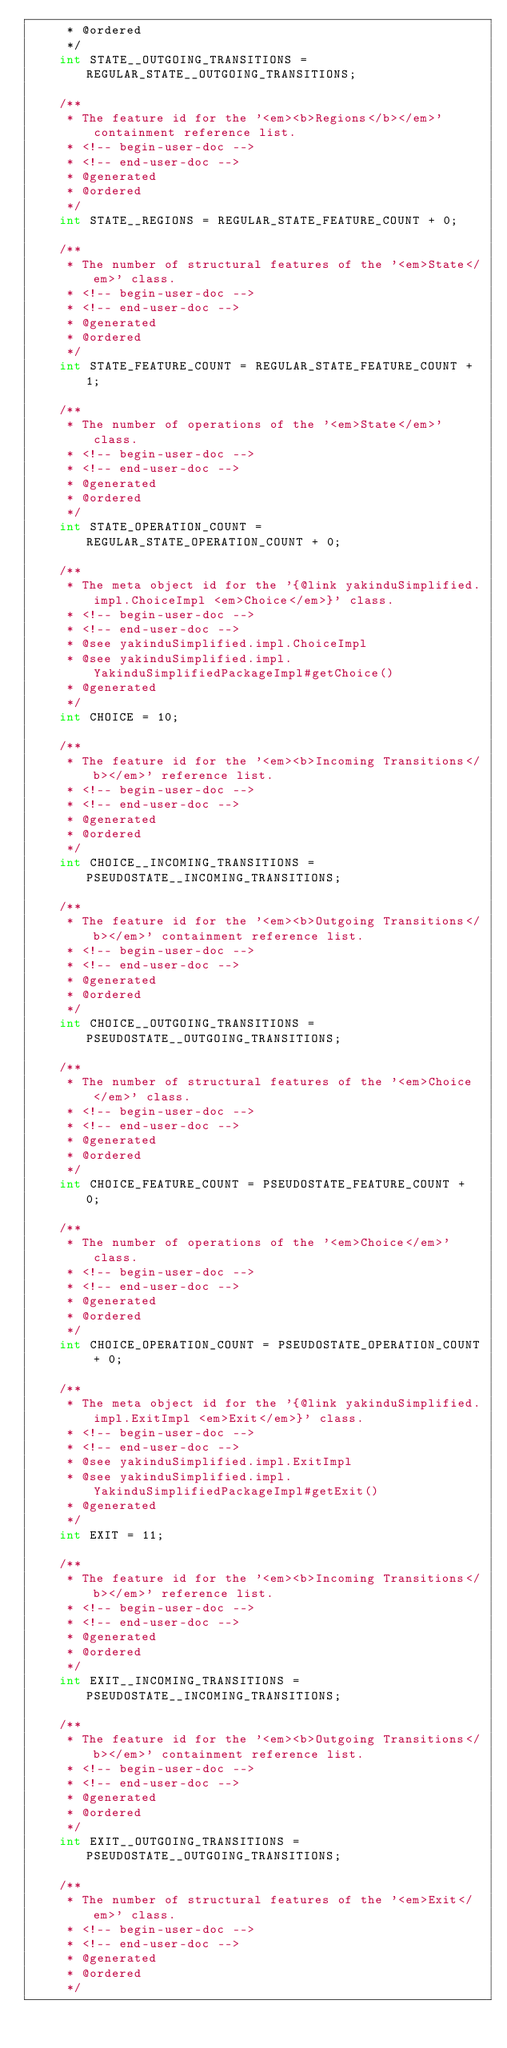Convert code to text. <code><loc_0><loc_0><loc_500><loc_500><_Java_>	 * @ordered
	 */
	int STATE__OUTGOING_TRANSITIONS = REGULAR_STATE__OUTGOING_TRANSITIONS;

	/**
	 * The feature id for the '<em><b>Regions</b></em>' containment reference list.
	 * <!-- begin-user-doc -->
	 * <!-- end-user-doc -->
	 * @generated
	 * @ordered
	 */
	int STATE__REGIONS = REGULAR_STATE_FEATURE_COUNT + 0;

	/**
	 * The number of structural features of the '<em>State</em>' class.
	 * <!-- begin-user-doc -->
	 * <!-- end-user-doc -->
	 * @generated
	 * @ordered
	 */
	int STATE_FEATURE_COUNT = REGULAR_STATE_FEATURE_COUNT + 1;

	/**
	 * The number of operations of the '<em>State</em>' class.
	 * <!-- begin-user-doc -->
	 * <!-- end-user-doc -->
	 * @generated
	 * @ordered
	 */
	int STATE_OPERATION_COUNT = REGULAR_STATE_OPERATION_COUNT + 0;

	/**
	 * The meta object id for the '{@link yakinduSimplified.impl.ChoiceImpl <em>Choice</em>}' class.
	 * <!-- begin-user-doc -->
	 * <!-- end-user-doc -->
	 * @see yakinduSimplified.impl.ChoiceImpl
	 * @see yakinduSimplified.impl.YakinduSimplifiedPackageImpl#getChoice()
	 * @generated
	 */
	int CHOICE = 10;

	/**
	 * The feature id for the '<em><b>Incoming Transitions</b></em>' reference list.
	 * <!-- begin-user-doc -->
	 * <!-- end-user-doc -->
	 * @generated
	 * @ordered
	 */
	int CHOICE__INCOMING_TRANSITIONS = PSEUDOSTATE__INCOMING_TRANSITIONS;

	/**
	 * The feature id for the '<em><b>Outgoing Transitions</b></em>' containment reference list.
	 * <!-- begin-user-doc -->
	 * <!-- end-user-doc -->
	 * @generated
	 * @ordered
	 */
	int CHOICE__OUTGOING_TRANSITIONS = PSEUDOSTATE__OUTGOING_TRANSITIONS;

	/**
	 * The number of structural features of the '<em>Choice</em>' class.
	 * <!-- begin-user-doc -->
	 * <!-- end-user-doc -->
	 * @generated
	 * @ordered
	 */
	int CHOICE_FEATURE_COUNT = PSEUDOSTATE_FEATURE_COUNT + 0;

	/**
	 * The number of operations of the '<em>Choice</em>' class.
	 * <!-- begin-user-doc -->
	 * <!-- end-user-doc -->
	 * @generated
	 * @ordered
	 */
	int CHOICE_OPERATION_COUNT = PSEUDOSTATE_OPERATION_COUNT + 0;

	/**
	 * The meta object id for the '{@link yakinduSimplified.impl.ExitImpl <em>Exit</em>}' class.
	 * <!-- begin-user-doc -->
	 * <!-- end-user-doc -->
	 * @see yakinduSimplified.impl.ExitImpl
	 * @see yakinduSimplified.impl.YakinduSimplifiedPackageImpl#getExit()
	 * @generated
	 */
	int EXIT = 11;

	/**
	 * The feature id for the '<em><b>Incoming Transitions</b></em>' reference list.
	 * <!-- begin-user-doc -->
	 * <!-- end-user-doc -->
	 * @generated
	 * @ordered
	 */
	int EXIT__INCOMING_TRANSITIONS = PSEUDOSTATE__INCOMING_TRANSITIONS;

	/**
	 * The feature id for the '<em><b>Outgoing Transitions</b></em>' containment reference list.
	 * <!-- begin-user-doc -->
	 * <!-- end-user-doc -->
	 * @generated
	 * @ordered
	 */
	int EXIT__OUTGOING_TRANSITIONS = PSEUDOSTATE__OUTGOING_TRANSITIONS;

	/**
	 * The number of structural features of the '<em>Exit</em>' class.
	 * <!-- begin-user-doc -->
	 * <!-- end-user-doc -->
	 * @generated
	 * @ordered
	 */</code> 